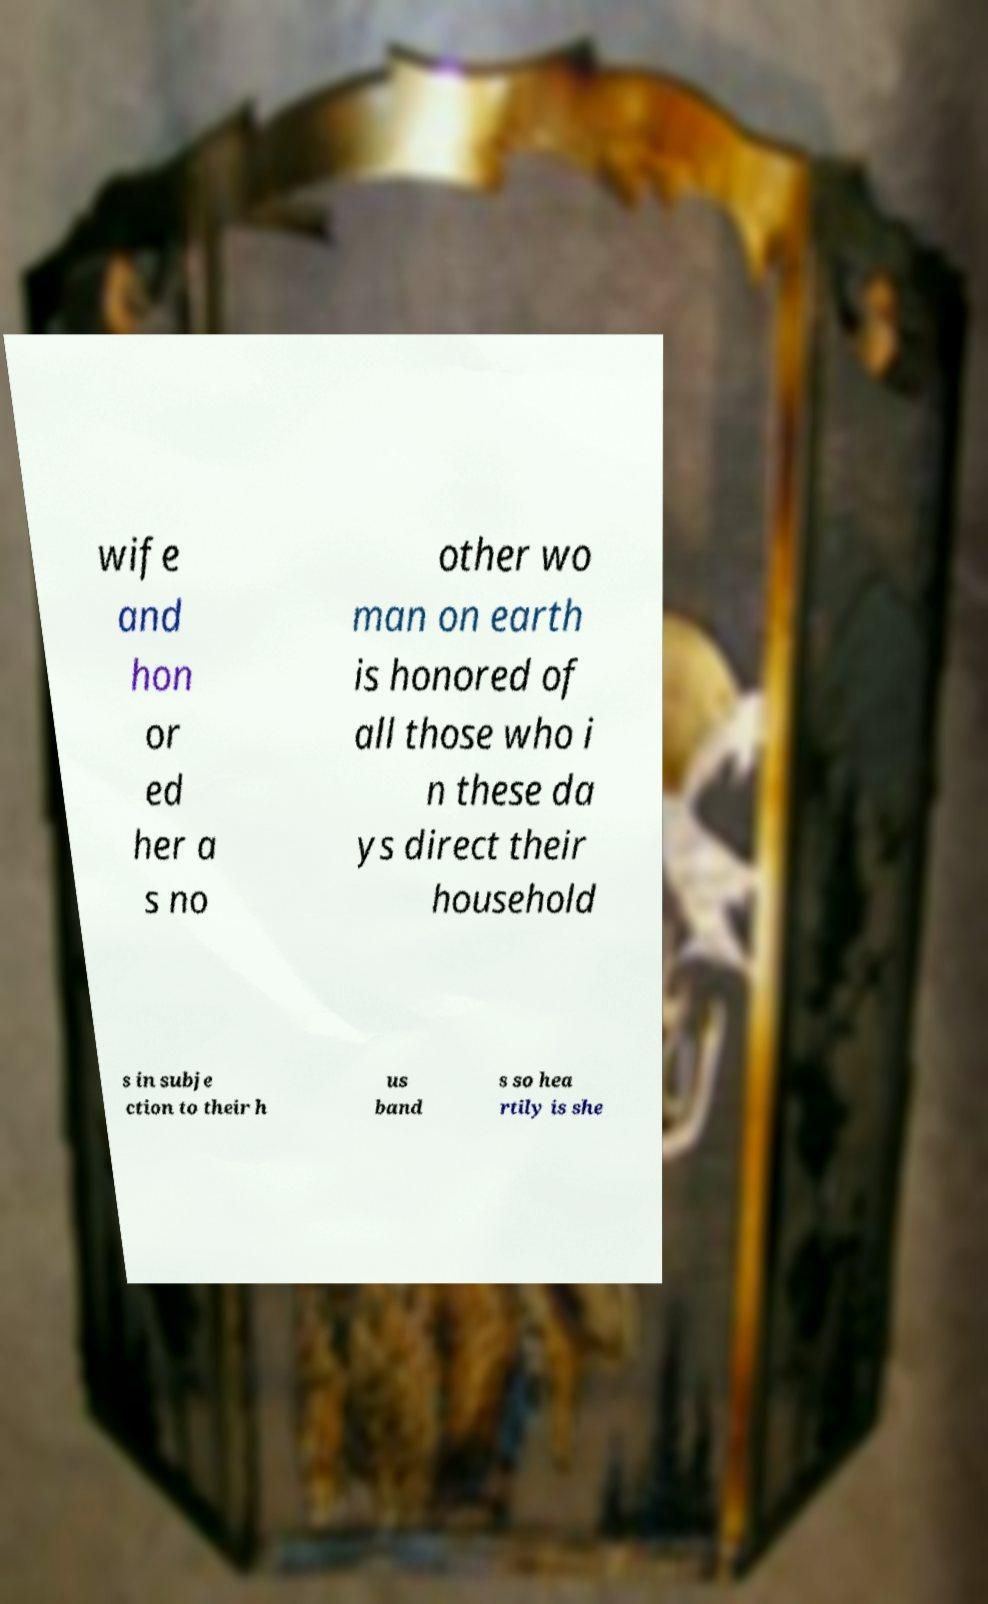Could you extract and type out the text from this image? wife and hon or ed her a s no other wo man on earth is honored of all those who i n these da ys direct their household s in subje ction to their h us band s so hea rtily is she 